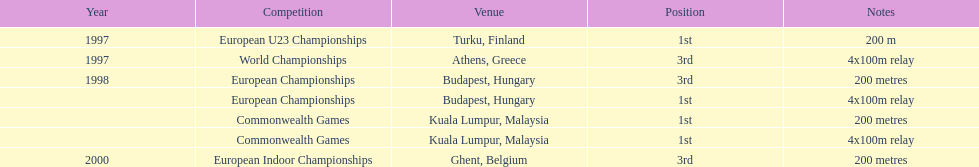Between 1997 and 2000, in which year did julian golding, a sprinter from the uk and england, win both the 4x100m relay and the 200m race? 1998. 